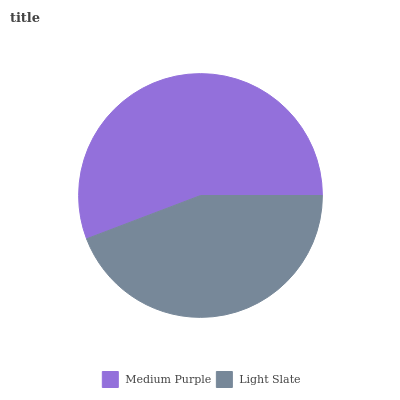Is Light Slate the minimum?
Answer yes or no. Yes. Is Medium Purple the maximum?
Answer yes or no. Yes. Is Light Slate the maximum?
Answer yes or no. No. Is Medium Purple greater than Light Slate?
Answer yes or no. Yes. Is Light Slate less than Medium Purple?
Answer yes or no. Yes. Is Light Slate greater than Medium Purple?
Answer yes or no. No. Is Medium Purple less than Light Slate?
Answer yes or no. No. Is Medium Purple the high median?
Answer yes or no. Yes. Is Light Slate the low median?
Answer yes or no. Yes. Is Light Slate the high median?
Answer yes or no. No. Is Medium Purple the low median?
Answer yes or no. No. 